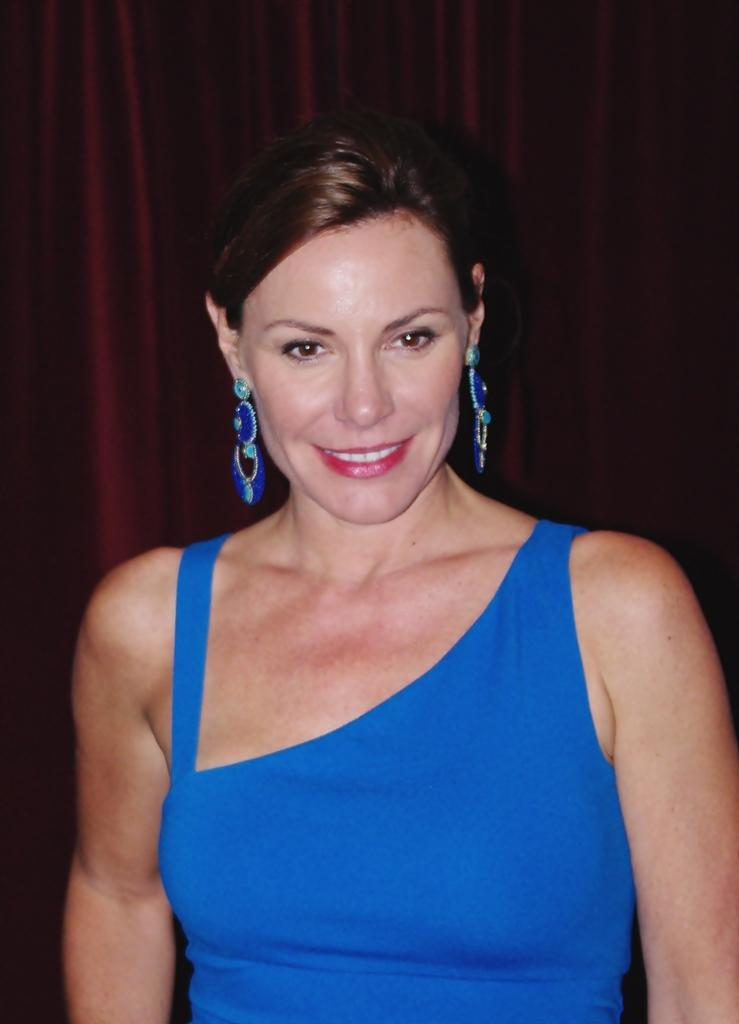Who is the main subject in the image? There is a woman in the image. What is the woman wearing? The woman is wearing a blue dress. What expression does the woman have? The woman is smiling. What might be the reason for the woman's pose in the image? The woman might be posing for the photo. What color is the sheet in the background of the image? There is a sheet in maroon color in the background of the image. Can you tell me where the kettle is located in the image? There is no kettle present in the image. What type of dog can be seen playing with the woman in the image? There is no dog present in the image. 